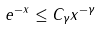Convert formula to latex. <formula><loc_0><loc_0><loc_500><loc_500>e ^ { - x } \leq C _ { \gamma } x ^ { - \gamma }</formula> 